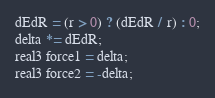Convert code to text. <code><loc_0><loc_0><loc_500><loc_500><_Cuda_>dEdR = (r > 0) ? (dEdR / r) : 0;
delta *= dEdR;
real3 force1 = delta;
real3 force2 = -delta;
</code> 